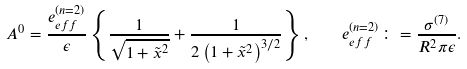<formula> <loc_0><loc_0><loc_500><loc_500>A ^ { 0 } = \frac { e ^ { ( n = 2 ) } _ { e f f } } { \epsilon } \left \{ \frac { 1 } { \sqrt { 1 + \tilde { x } ^ { 2 } } } + \frac { 1 } { 2 \left ( 1 + \tilde { x } ^ { 2 } \right ) ^ { 3 / 2 } } \right \} , \quad e ^ { ( n = 2 ) } _ { e f f } \colon = \frac { \sigma ^ { ( 7 ) } } { R ^ { 2 } \pi \epsilon } .</formula> 